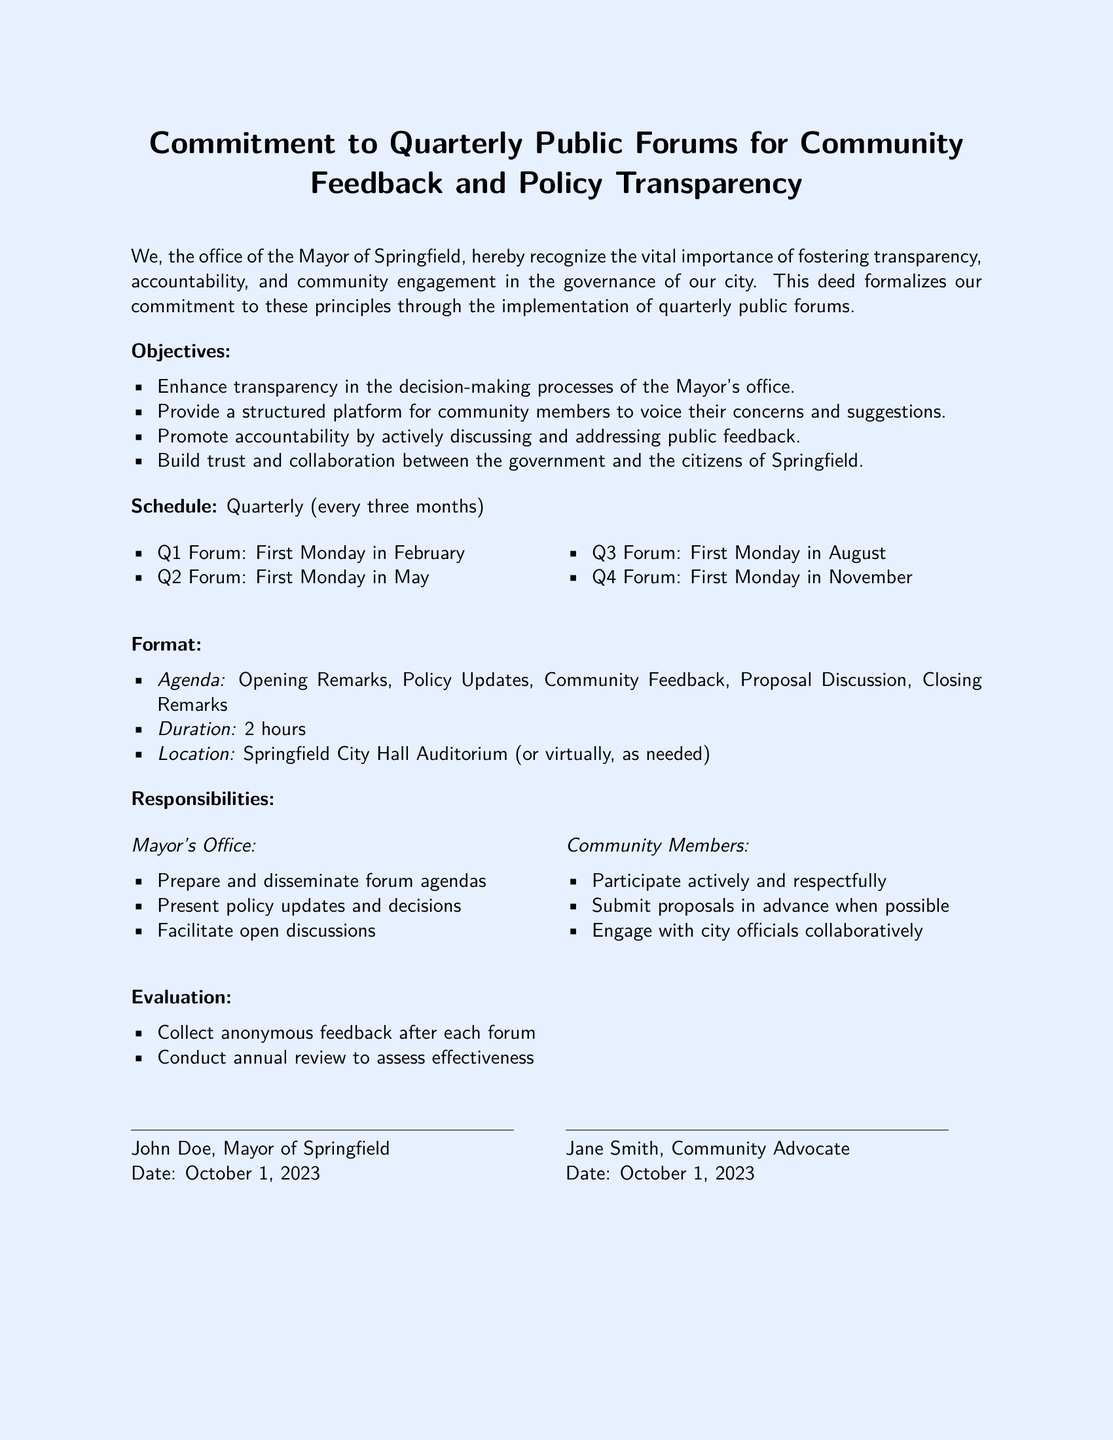What is the title of the document? The title reflects the primary subject of the deed, which is the commitment to community engagement.
Answer: Commitment to Quarterly Public Forums for Community Feedback and Policy Transparency Who is the author of the document? The document is authored by the office of the Mayor of Springfield, specifically denoted within the text.
Answer: Mayor of Springfield How often will public forums be held? The text specifies the schedule for the forums, which is on a quarterly basis.
Answer: Quarterly What day is the first forum scheduled? The document lists the specific day for the first forum in the first quarter, which is the first Monday in February.
Answer: First Monday in February What are community members expected to do at the forums? The document outlines responsibilities for community members, including active participation and collaboration.
Answer: Participate actively and respectfully How will feedback be collected post-forum? The document indicates that anonymous feedback will be collected after each forum.
Answer: Anonymous feedback What will be included in the forum format? The agenda lists the key components of the public forums, outlining the structure of each meeting.
Answer: Opening Remarks, Policy Updates, Community Feedback, Proposal Discussion, Closing Remarks What is the evaluation process mentioned in the document? The document describes the methods for assessing the effectiveness of the forums, which includes collecting feedback and conducting a review.
Answer: Collect anonymous feedback after each forum Who signed the document along with the Mayor? The document indicates that a community advocate co-signed the deed along with the Mayor.
Answer: Jane Smith, Community Advocate 